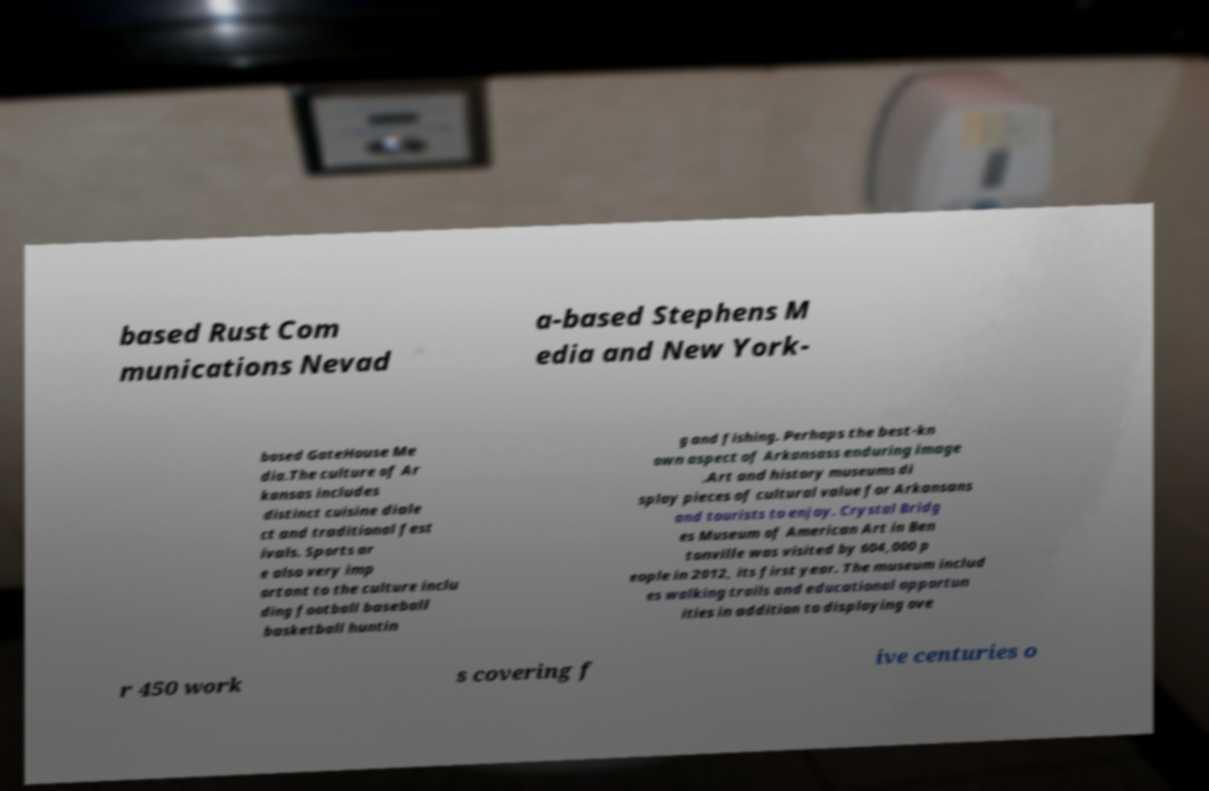I need the written content from this picture converted into text. Can you do that? based Rust Com munications Nevad a-based Stephens M edia and New York- based GateHouse Me dia.The culture of Ar kansas includes distinct cuisine diale ct and traditional fest ivals. Sports ar e also very imp ortant to the culture inclu ding football baseball basketball huntin g and fishing. Perhaps the best-kn own aspect of Arkansass enduring image .Art and history museums di splay pieces of cultural value for Arkansans and tourists to enjoy. Crystal Bridg es Museum of American Art in Ben tonville was visited by 604,000 p eople in 2012, its first year. The museum includ es walking trails and educational opportun ities in addition to displaying ove r 450 work s covering f ive centuries o 